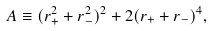<formula> <loc_0><loc_0><loc_500><loc_500>A \equiv ( r _ { + } ^ { 2 } + r _ { - } ^ { 2 } ) ^ { 2 } + 2 ( r _ { + } + r _ { - } ) ^ { 4 } ,</formula> 